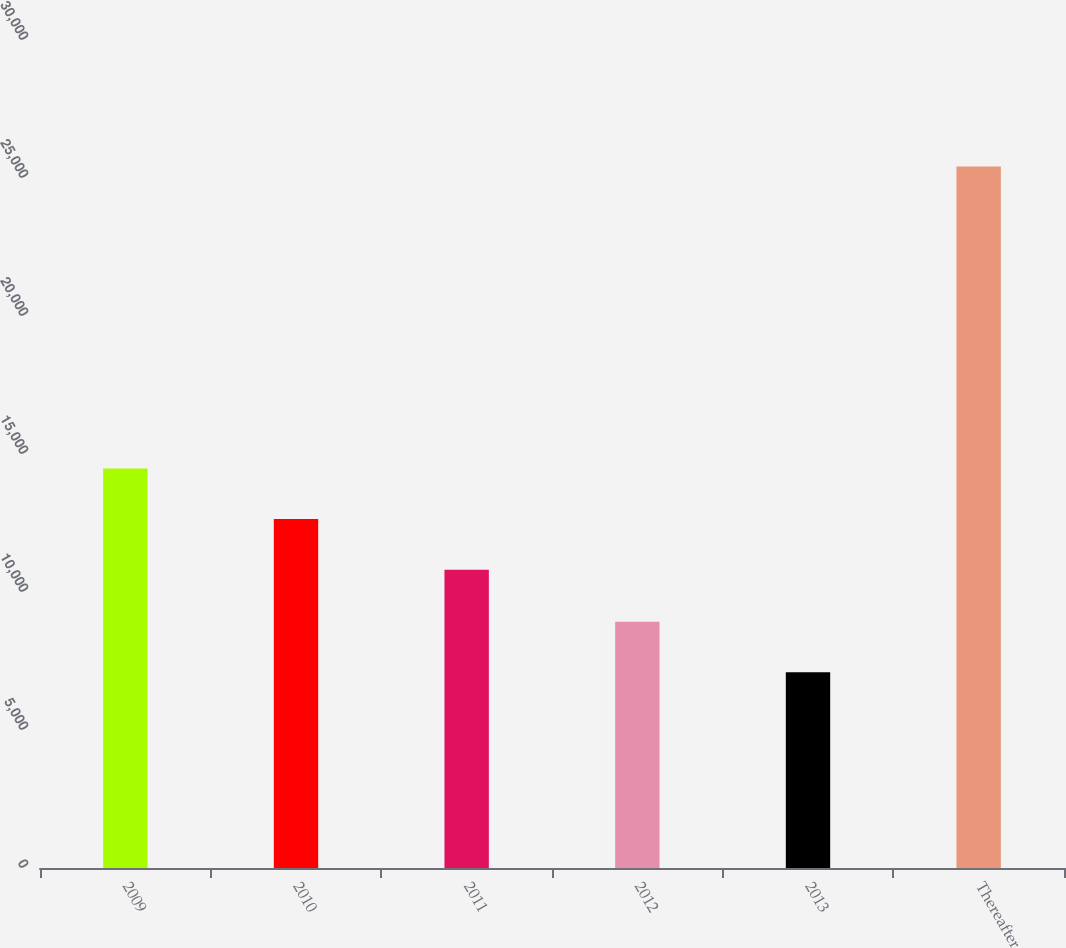Convert chart to OTSL. <chart><loc_0><loc_0><loc_500><loc_500><bar_chart><fcel>2009<fcel>2010<fcel>2011<fcel>2012<fcel>2013<fcel>Thereafter<nl><fcel>14474.2<fcel>12642.1<fcel>10810<fcel>8925.1<fcel>7093<fcel>25414<nl></chart> 